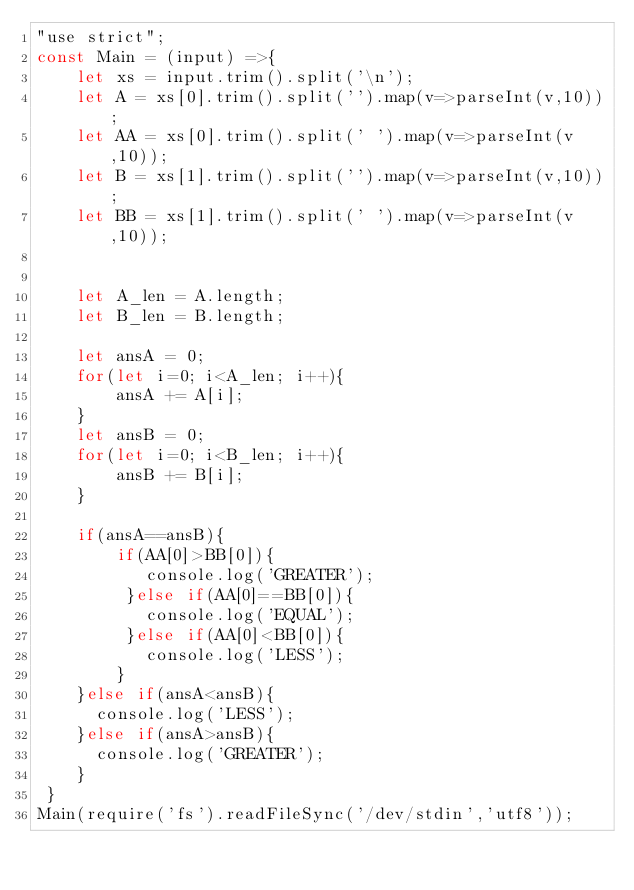<code> <loc_0><loc_0><loc_500><loc_500><_JavaScript_>"use strict";
const Main = (input) =>{
	let xs = input.trim().split('\n');    
    let A = xs[0].trim().split('').map(v=>parseInt(v,10));
    let AA = xs[0].trim().split(' ').map(v=>parseInt(v,10));
    let B = xs[1].trim().split('').map(v=>parseInt(v,10));
    let BB = xs[1].trim().split(' ').map(v=>parseInt(v,10));
    
    
    let A_len = A.length;
    let B_len = B.length;
    
    let ansA = 0;
    for(let i=0; i<A_len; i++){
        ansA += A[i]; 
    }
    let ansB = 0;
    for(let i=0; i<B_len; i++){
        ansB += B[i]; 
    }  
  
    if(ansA==ansB){
        if(AA[0]>BB[0]){
           console.log('GREATER');
         }else if(AA[0]==BB[0]){
           console.log('EQUAL');
         }else if(AA[0]<BB[0]){
           console.log('LESS');
        }
    }else if(ansA<ansB){
      console.log('LESS');
    }else if(ansA>ansB){
      console.log('GREATER');
    }
 }
Main(require('fs').readFileSync('/dev/stdin','utf8'));</code> 